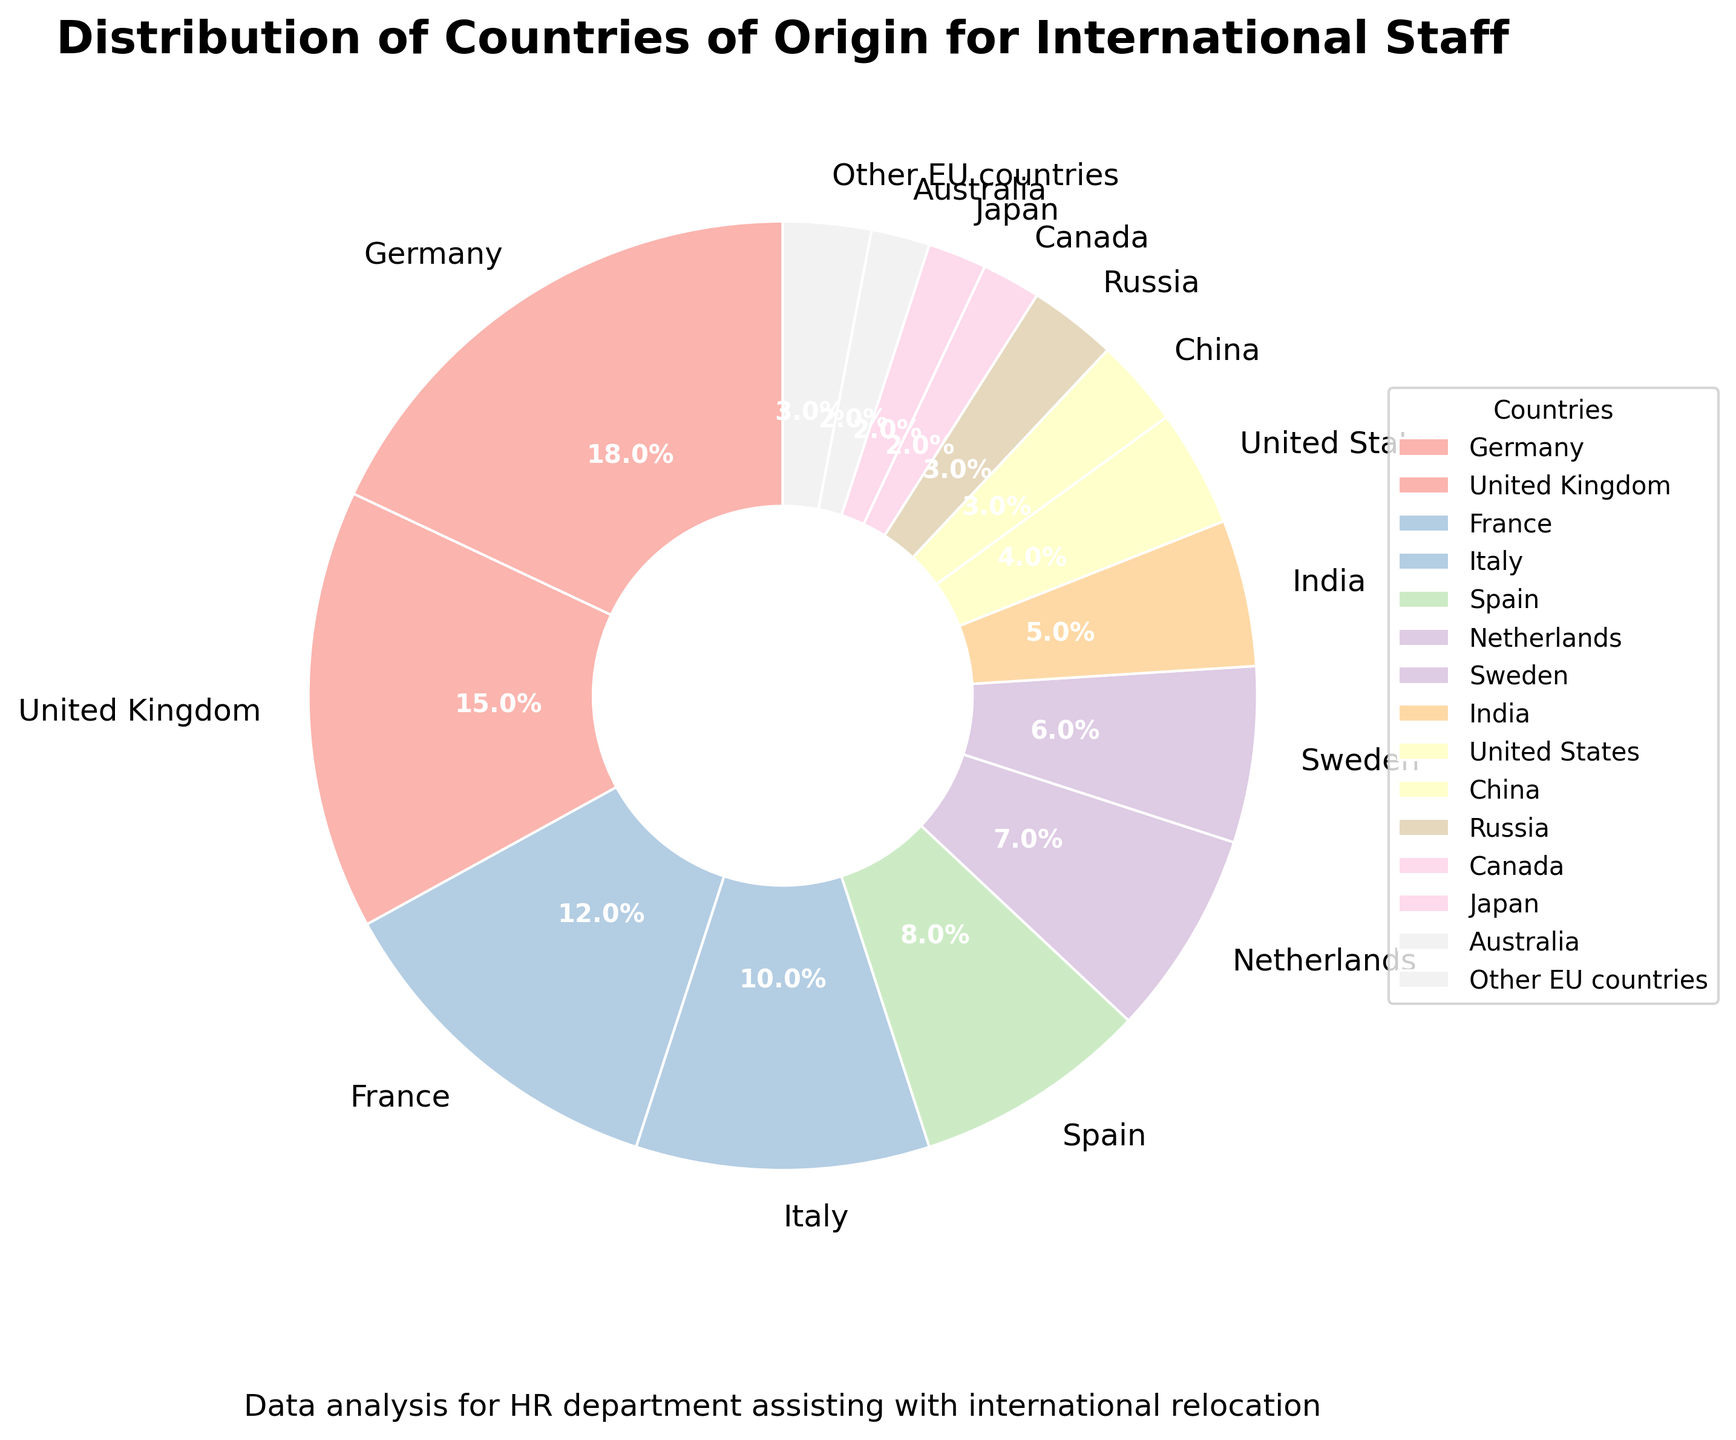What is the country of origin with the highest percentage of international staff? The country with the highest percentage can be identified by finding the largest slice in the pie chart, which is labeled "Germany" with 18%.
Answer: Germany Which country has a lower percentage of international staff, Sweden or Netherlands? To compare the percentages of Sweden and Netherlands, check their labels on the pie chart. Sweden has 6% while Netherlands has 7%, so Sweden has a lower percentage.
Answer: Sweden What is the combined percentage of staff from the United Kingdom and Canada? Add the percentages for the United Kingdom (15%) and Canada (2%). The total is 15% + 2% = 17%.
Answer: 17% How many countries have a percentage of international staff less than 5%? Identify the countries with percentages less than 5%: United States (4%), China (3%), Russia (3%), Canada (2%), Japan (2%), Australia (2%), Other EU countries (3%). There are 7 countries.
Answer: 7 Which country has a percentage equal to France? The pie chart label for France shows 12%. No other country shares this exact percentage. Hence, only France has 12%.
Answer: France What percentage does Italy contribute more than Japan? Subtract Japan’s percentage from Italy’s percentage: 10% (Italy) - 2% (Japan) = 8%.
Answer: 8% What is the average percentage of staff from Germany, France, and Spain? Add the percentages of Germany (18%), France (12%), and Spain (8%), then divide by 3: (18% + 12% + 8%) / 3 = 38% / 3 ≈ 12.67%.
Answer: 12.67% Is the percentage of international staff from India higher or lower compared to Australia? Compare the percentages for India and Australia. India has 5% while Australia has 2%. India is higher.
Answer: Higher Do more than 50% of the international staff come from the top three countries? Add the percentages of the top three countries: Germany (18%), United Kingdom (15%), and France (12%). The sum is 18% + 15% + 12% = 45%, which is less than 50%.
Answer: No 